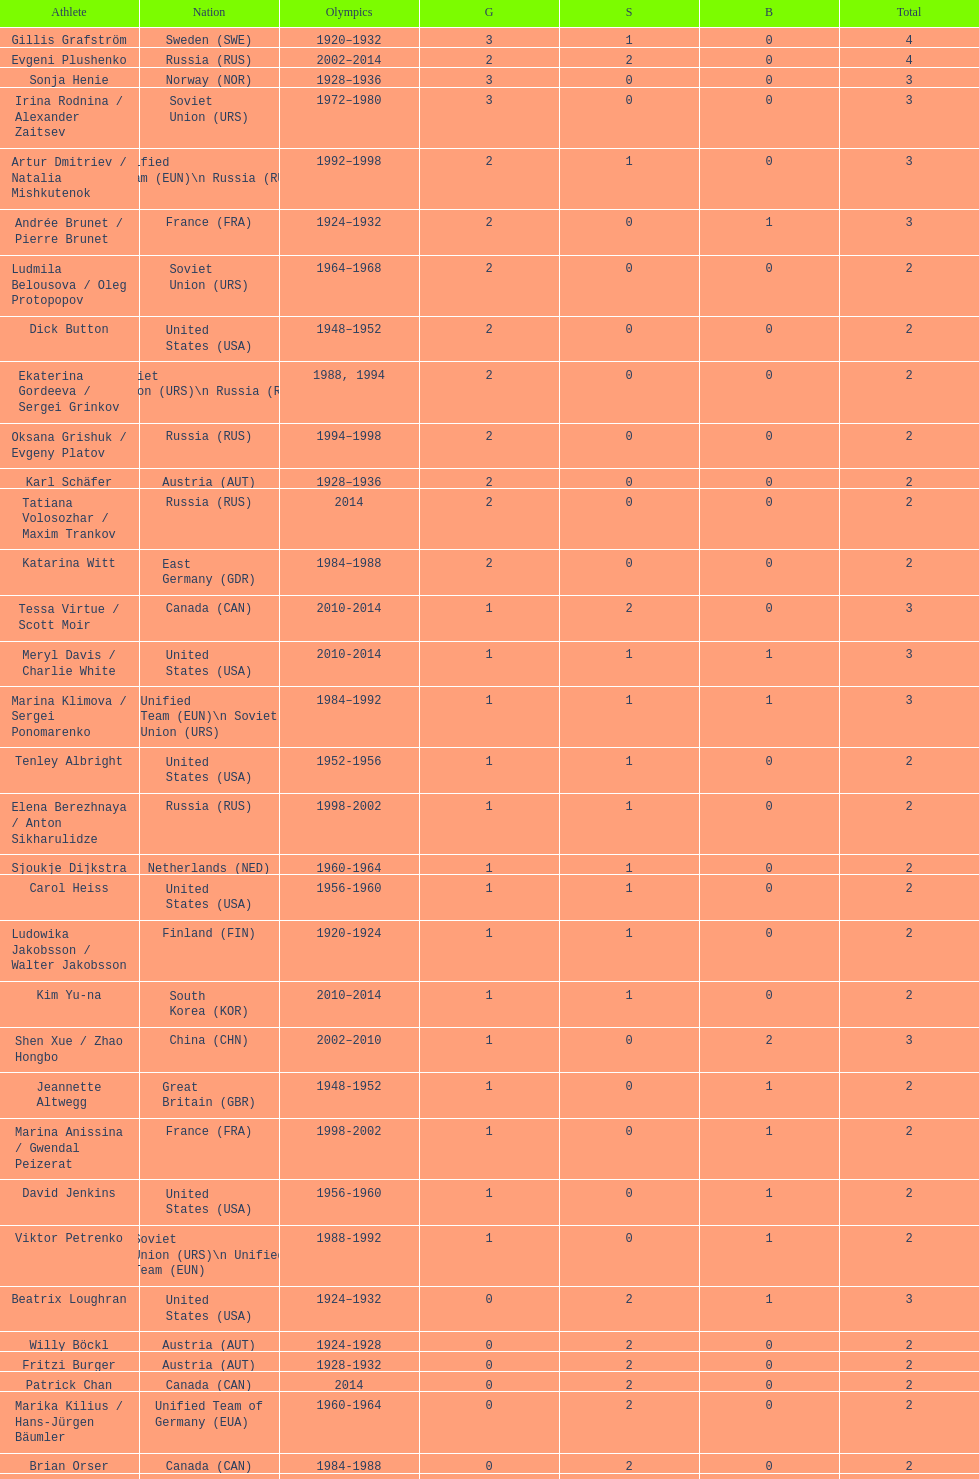How many medals have sweden and norway won combined? 7. 